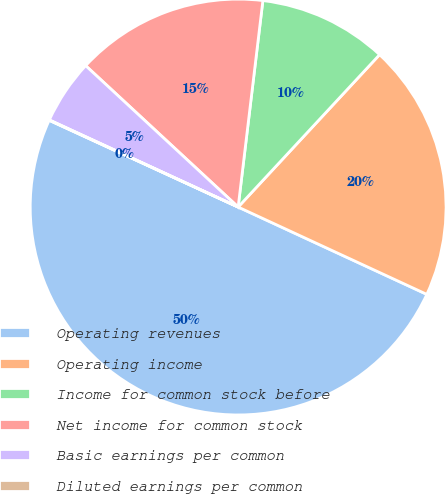Convert chart. <chart><loc_0><loc_0><loc_500><loc_500><pie_chart><fcel>Operating revenues<fcel>Operating income<fcel>Income for common stock before<fcel>Net income for common stock<fcel>Basic earnings per common<fcel>Diluted earnings per common<nl><fcel>49.95%<fcel>19.99%<fcel>10.01%<fcel>15.0%<fcel>5.02%<fcel>0.03%<nl></chart> 